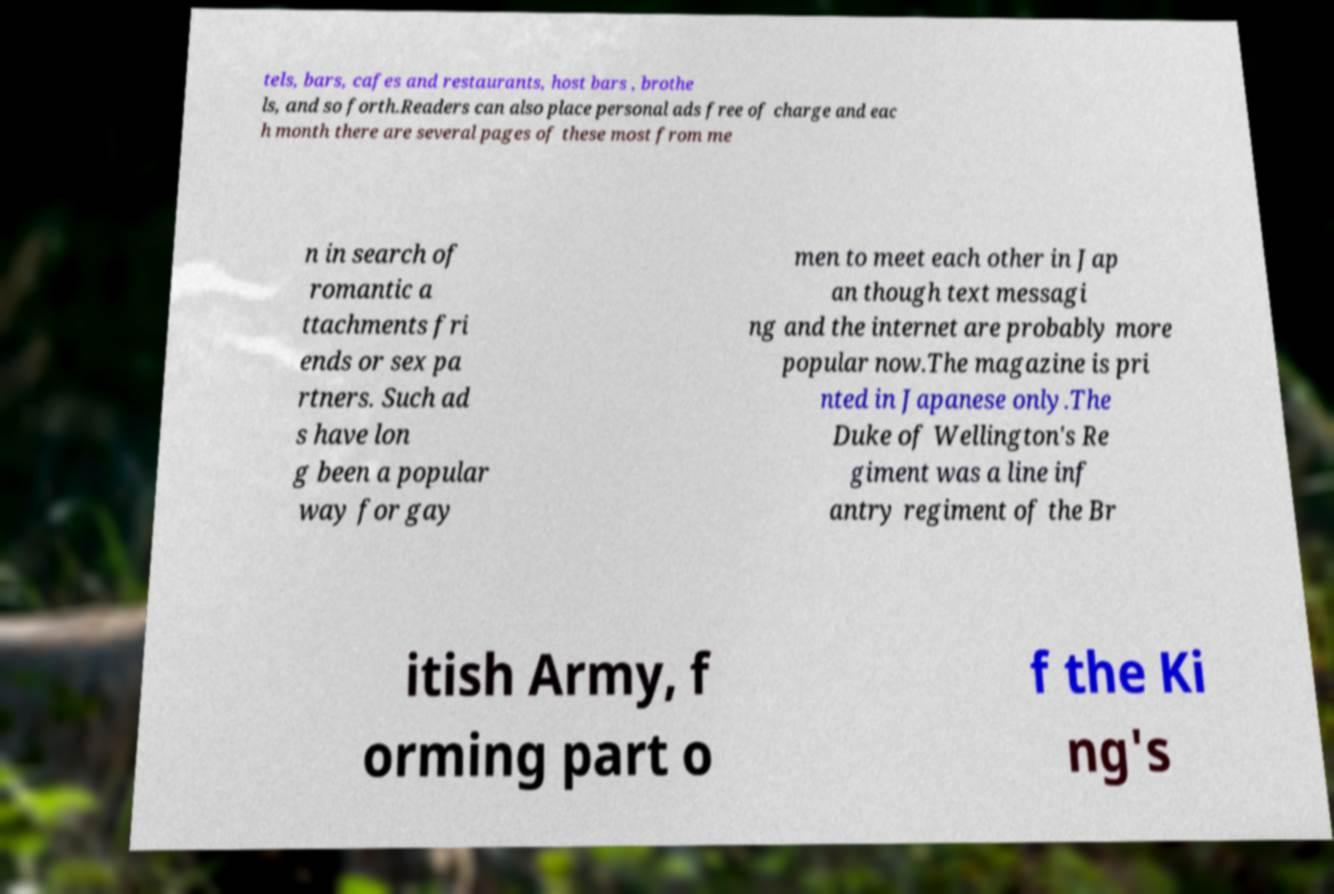For documentation purposes, I need the text within this image transcribed. Could you provide that? tels, bars, cafes and restaurants, host bars , brothe ls, and so forth.Readers can also place personal ads free of charge and eac h month there are several pages of these most from me n in search of romantic a ttachments fri ends or sex pa rtners. Such ad s have lon g been a popular way for gay men to meet each other in Jap an though text messagi ng and the internet are probably more popular now.The magazine is pri nted in Japanese only.The Duke of Wellington's Re giment was a line inf antry regiment of the Br itish Army, f orming part o f the Ki ng's 